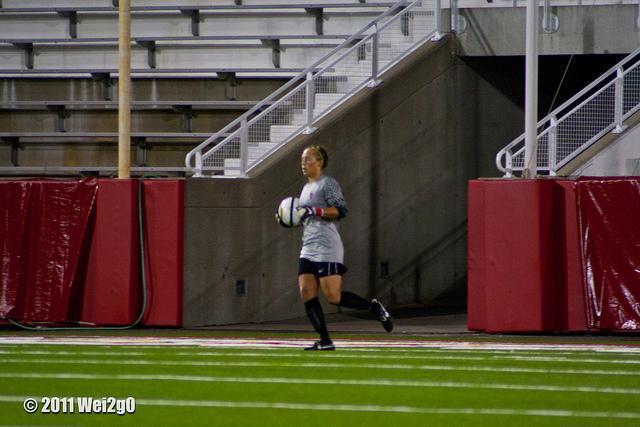How many benches are there?
Give a very brief answer. 4. 